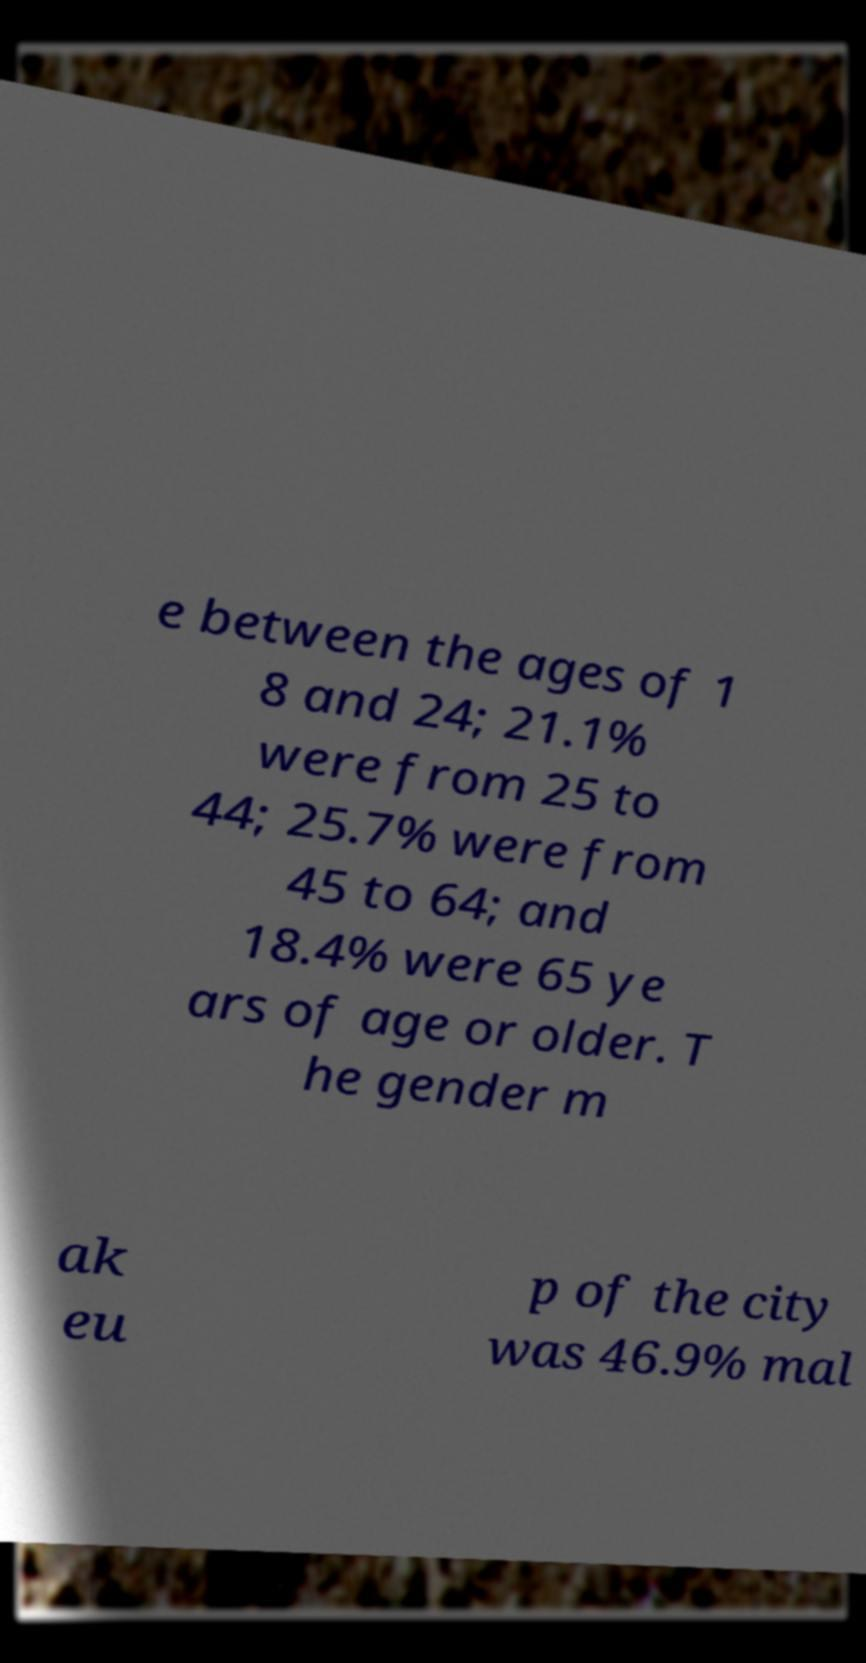Can you read and provide the text displayed in the image?This photo seems to have some interesting text. Can you extract and type it out for me? e between the ages of 1 8 and 24; 21.1% were from 25 to 44; 25.7% were from 45 to 64; and 18.4% were 65 ye ars of age or older. T he gender m ak eu p of the city was 46.9% mal 